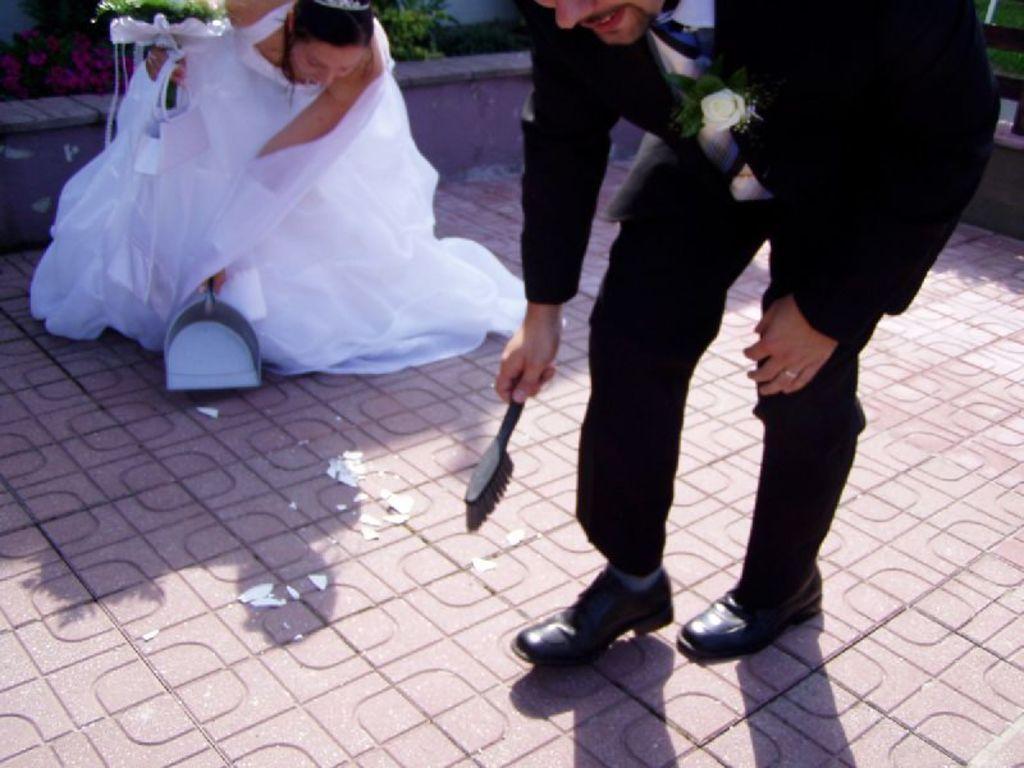How would you summarize this image in a sentence or two? In this image there is a floor, on that floor there is a man and woman bending holding stick and plastic dust pan in their hands, in the background there are plants. 